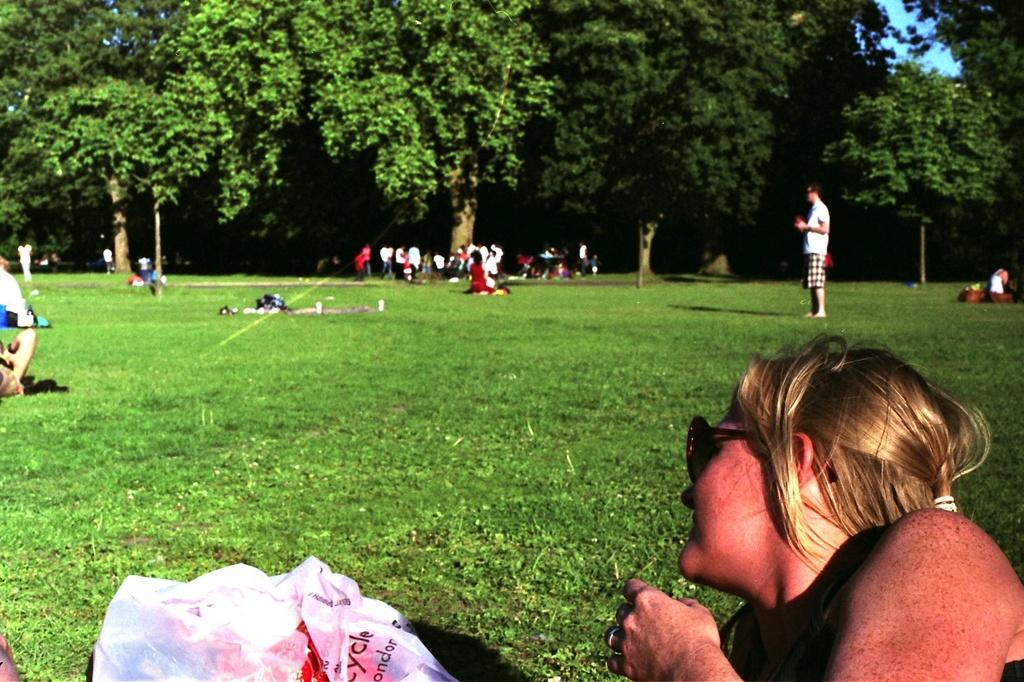Who is at the bottom of the image? There is a lady at the bottom of the image. What object can be seen in the image besides the lady? There is a plastic bag in the image. What type of terrain is visible in the image? Grass is present on the ground. How many people are in the image? There are many people in the image. What can be seen in the background of the image? There are trees in the background of the image. How many spiders are crawling on the lady in the image? There are no spiders visible in the image, so it is not possible to determine their number. What type of structure is present in the image? There is no specific structure mentioned in the provided facts, so it cannot be determined from the image. 